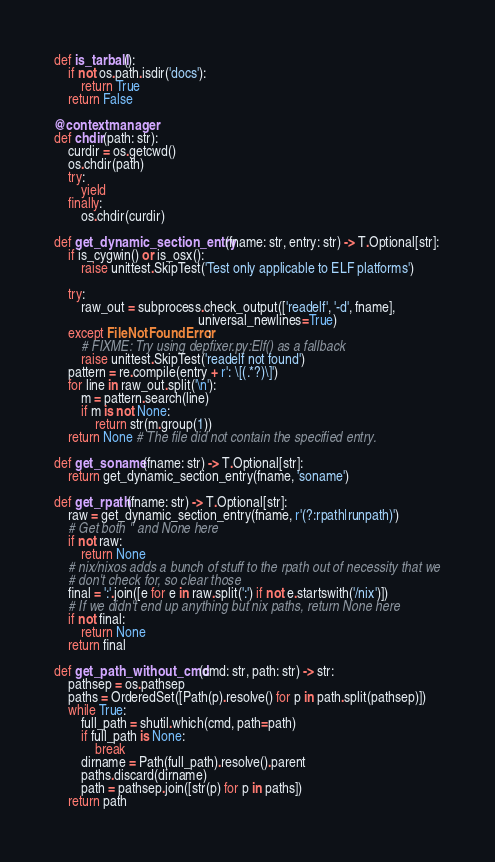Convert code to text. <code><loc_0><loc_0><loc_500><loc_500><_Python_>
def is_tarball():
    if not os.path.isdir('docs'):
        return True
    return False

@contextmanager
def chdir(path: str):
    curdir = os.getcwd()
    os.chdir(path)
    try:
        yield
    finally:
        os.chdir(curdir)

def get_dynamic_section_entry(fname: str, entry: str) -> T.Optional[str]:
    if is_cygwin() or is_osx():
        raise unittest.SkipTest('Test only applicable to ELF platforms')

    try:
        raw_out = subprocess.check_output(['readelf', '-d', fname],
                                          universal_newlines=True)
    except FileNotFoundError:
        # FIXME: Try using depfixer.py:Elf() as a fallback
        raise unittest.SkipTest('readelf not found')
    pattern = re.compile(entry + r': \[(.*?)\]')
    for line in raw_out.split('\n'):
        m = pattern.search(line)
        if m is not None:
            return str(m.group(1))
    return None # The file did not contain the specified entry.

def get_soname(fname: str) -> T.Optional[str]:
    return get_dynamic_section_entry(fname, 'soname')

def get_rpath(fname: str) -> T.Optional[str]:
    raw = get_dynamic_section_entry(fname, r'(?:rpath|runpath)')
    # Get both '' and None here
    if not raw:
        return None
    # nix/nixos adds a bunch of stuff to the rpath out of necessity that we
    # don't check for, so clear those
    final = ':'.join([e for e in raw.split(':') if not e.startswith('/nix')])
    # If we didn't end up anything but nix paths, return None here
    if not final:
        return None
    return final

def get_path_without_cmd(cmd: str, path: str) -> str:
    pathsep = os.pathsep
    paths = OrderedSet([Path(p).resolve() for p in path.split(pathsep)])
    while True:
        full_path = shutil.which(cmd, path=path)
        if full_path is None:
            break
        dirname = Path(full_path).resolve().parent
        paths.discard(dirname)
        path = pathsep.join([str(p) for p in paths])
    return path
</code> 